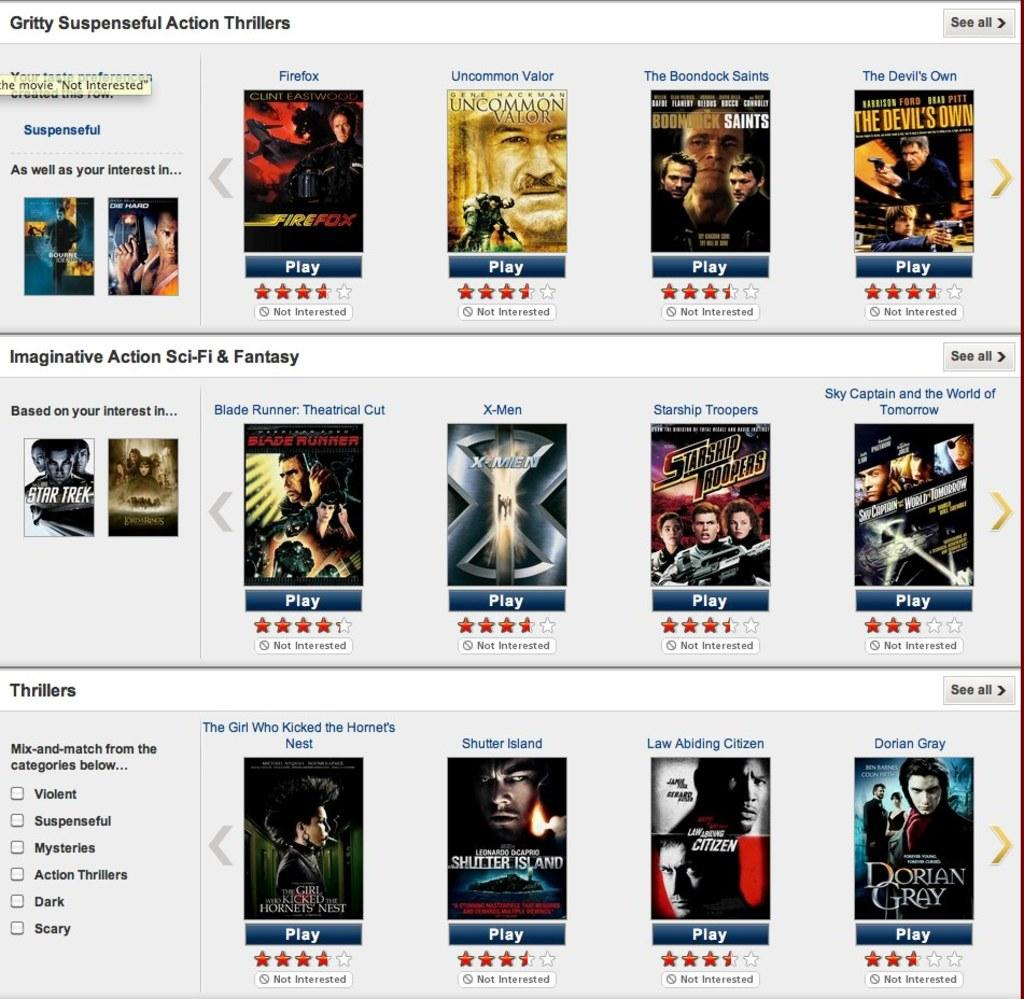<image>
Write a terse but informative summary of the picture. A website shows a list of gritty suspenseful action thrillers. 